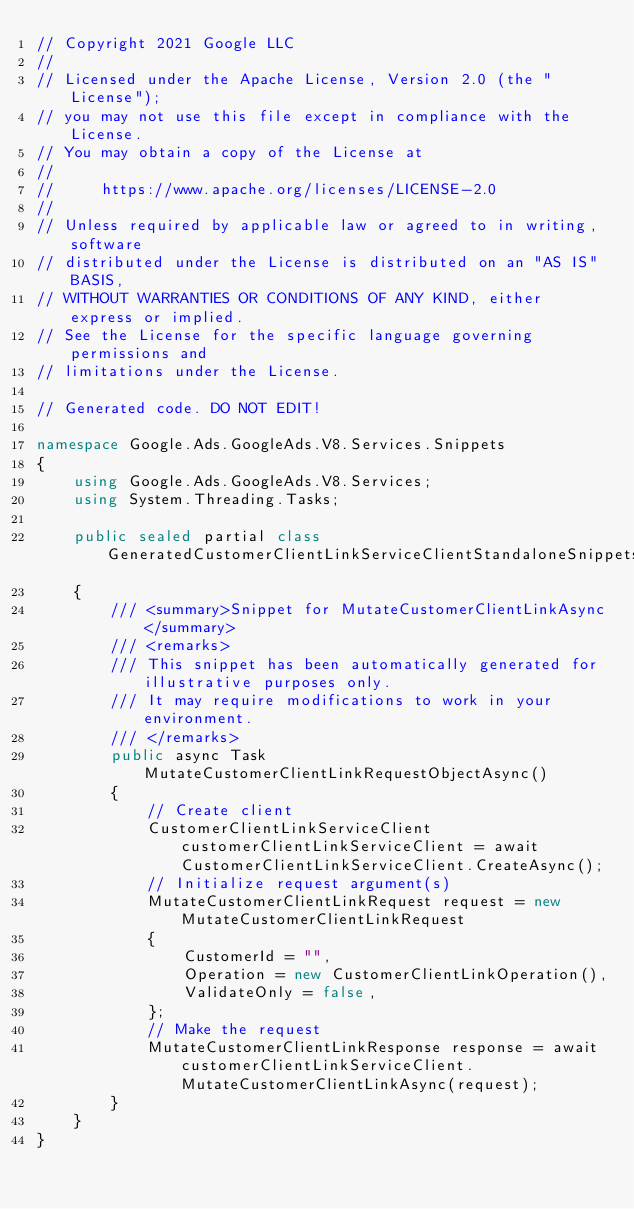Convert code to text. <code><loc_0><loc_0><loc_500><loc_500><_C#_>// Copyright 2021 Google LLC
//
// Licensed under the Apache License, Version 2.0 (the "License");
// you may not use this file except in compliance with the License.
// You may obtain a copy of the License at
//
//     https://www.apache.org/licenses/LICENSE-2.0
//
// Unless required by applicable law or agreed to in writing, software
// distributed under the License is distributed on an "AS IS" BASIS,
// WITHOUT WARRANTIES OR CONDITIONS OF ANY KIND, either express or implied.
// See the License for the specific language governing permissions and
// limitations under the License.

// Generated code. DO NOT EDIT!

namespace Google.Ads.GoogleAds.V8.Services.Snippets
{
    using Google.Ads.GoogleAds.V8.Services;
    using System.Threading.Tasks;

    public sealed partial class GeneratedCustomerClientLinkServiceClientStandaloneSnippets
    {
        /// <summary>Snippet for MutateCustomerClientLinkAsync</summary>
        /// <remarks>
        /// This snippet has been automatically generated for illustrative purposes only.
        /// It may require modifications to work in your environment.
        /// </remarks>
        public async Task MutateCustomerClientLinkRequestObjectAsync()
        {
            // Create client
            CustomerClientLinkServiceClient customerClientLinkServiceClient = await CustomerClientLinkServiceClient.CreateAsync();
            // Initialize request argument(s)
            MutateCustomerClientLinkRequest request = new MutateCustomerClientLinkRequest
            {
                CustomerId = "",
                Operation = new CustomerClientLinkOperation(),
                ValidateOnly = false,
            };
            // Make the request
            MutateCustomerClientLinkResponse response = await customerClientLinkServiceClient.MutateCustomerClientLinkAsync(request);
        }
    }
}
</code> 